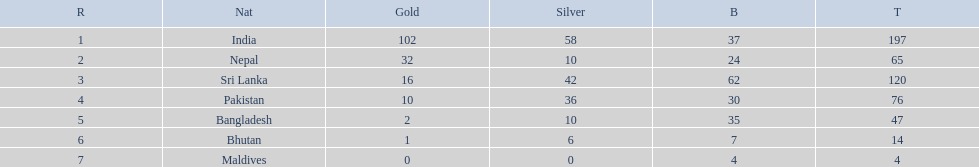What nations took part in 1999 south asian games? India, Nepal, Sri Lanka, Pakistan, Bangladesh, Bhutan, Maldives. Would you mind parsing the complete table? {'header': ['R', 'Nat', 'Gold', 'Silver', 'B', 'T'], 'rows': [['1', 'India', '102', '58', '37', '197'], ['2', 'Nepal', '32', '10', '24', '65'], ['3', 'Sri Lanka', '16', '42', '62', '120'], ['4', 'Pakistan', '10', '36', '30', '76'], ['5', 'Bangladesh', '2', '10', '35', '47'], ['6', 'Bhutan', '1', '6', '7', '14'], ['7', 'Maldives', '0', '0', '4', '4']]} Of those who earned gold medals? India, Nepal, Sri Lanka, Pakistan, Bangladesh, Bhutan. Which nation didn't earn any gold medals? Maldives. 